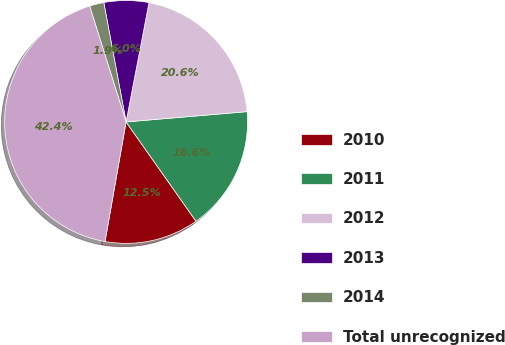<chart> <loc_0><loc_0><loc_500><loc_500><pie_chart><fcel>2010<fcel>2011<fcel>2012<fcel>2013<fcel>2014<fcel>Total unrecognized<nl><fcel>12.54%<fcel>16.59%<fcel>20.63%<fcel>5.96%<fcel>1.91%<fcel>42.38%<nl></chart> 